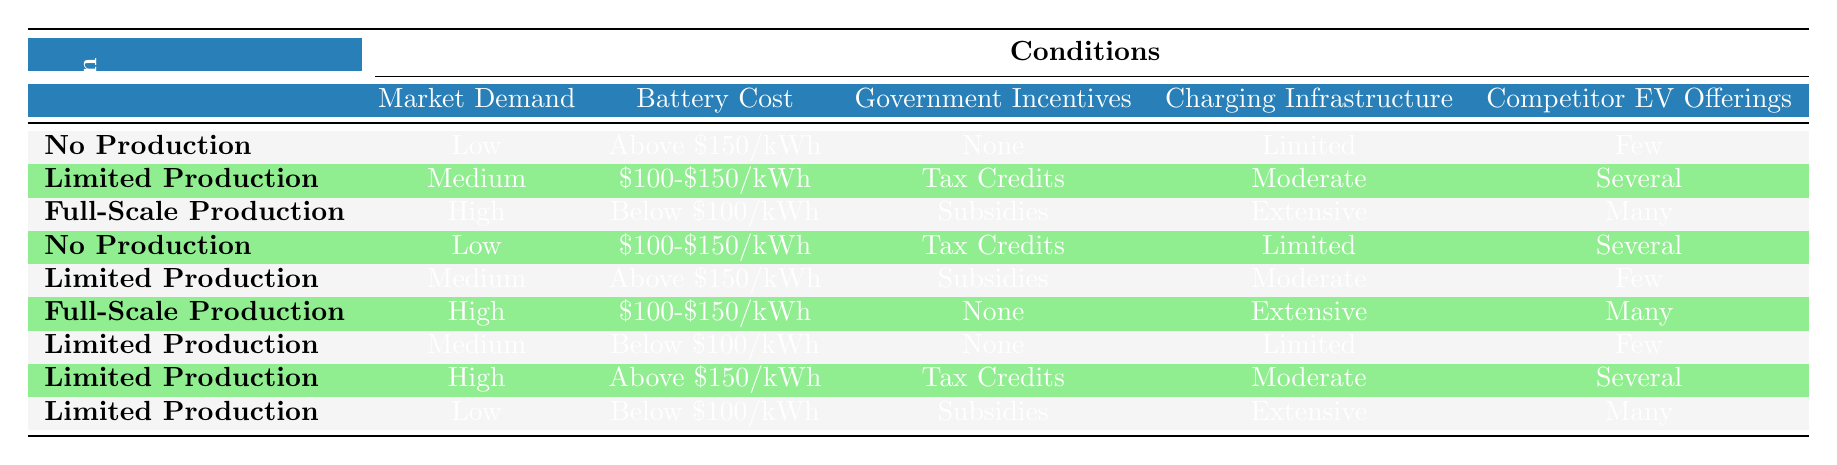What production decision is made when market demand is high and battery cost is below $100/kWh? According to the table, when the market demand is high and the battery cost is below $100/kWh, the action is “Full-Scale Production.”
Answer: Full-Scale Production Is there a situation where the production decision is "No Production"? Yes, there are two instances where "No Production" is the decision: when market demand is low with battery cost above $150/kWh and when market demand is low with battery cost between $100-$150/kWh with other specified conditions.
Answer: Yes How many conditions lead to "Limited Production" as the decision? By analyzing the table, there are four conditions that result in "Limited Production": one for medium market demand and various combinations of battery cost, incentives, infrastructure, and competitor offerings.
Answer: Four What is the relationship between government incentives and production decisions? The table shows that government incentives affect production decisions, as "Subsidies" and "Tax Credits" lead to either "Limited" or "Full-Scale Production," while "None" can also lead to "Limited Production" under certain conditions. Overall, the presence of incentives generally increases production likelihood.
Answer: Incentives increase production likelihood What is the minimum battery cost required for full-scale production if the market demand is high? When analyzing the table, for full-scale production with high market demand, the battery cost must be below $100/kWh or between $100-$150/kWh dependent on other conditions being satisfied.
Answer: Below $100/kWh or $100-$150/kWh What are the specific conditions that lead to "Full-Scale Production"? There are two sets of conditions that lead to full-scale production: (1) market demand must be high, battery cost below $100/kWh, government incentives in the form of subsidies, extensive infrastructure, and many competitor offerings; (2) high demand with battery cost between $100-$150/kWh, no government incentives, extensive infrastructure, and many competitors.
Answer: High demand and specific cost/conditions as noted Is it possible to have "Limited Production" with low market demand? Yes, according to the table, "Limited Production" can occur with low market demand if the battery cost is below $100/kWh and the charging infrastructure is extensive while having many competitor offerings.
Answer: Yes What is the impact of competitor EV offerings on production decisions? The presence of many competitor EV offerings often supports a decision for full-scale production or limited production, while few competitors tend to correlate with no production in certain markets and conditions according to the table.
Answer: Supports increased production decisions 